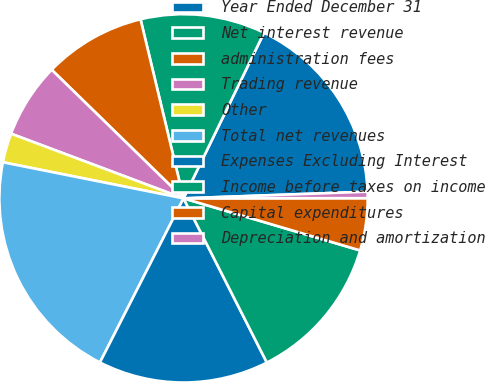Convert chart. <chart><loc_0><loc_0><loc_500><loc_500><pie_chart><fcel>Year Ended December 31<fcel>Net interest revenue<fcel>administration fees<fcel>Trading revenue<fcel>Other<fcel>Total net revenues<fcel>Expenses Excluding Interest<fcel>Income before taxes on income<fcel>Capital expenditures<fcel>Depreciation and amortization<nl><fcel>17.22%<fcel>10.95%<fcel>8.95%<fcel>6.59%<fcel>2.57%<fcel>20.64%<fcel>14.97%<fcel>12.96%<fcel>4.58%<fcel>0.56%<nl></chart> 